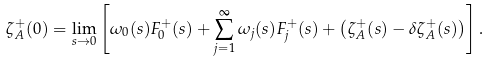Convert formula to latex. <formula><loc_0><loc_0><loc_500><loc_500>\zeta _ { A } ^ { + } ( 0 ) = \lim _ { s \to 0 } \left [ \omega _ { 0 } ( s ) F _ { 0 } ^ { + } ( s ) + \sum _ { j = 1 } ^ { \infty } \omega _ { j } ( s ) F _ { j } ^ { + } ( s ) + \left ( \zeta _ { A } ^ { + } ( s ) - \delta \zeta _ { A } ^ { + } ( s ) \right ) \right ] .</formula> 